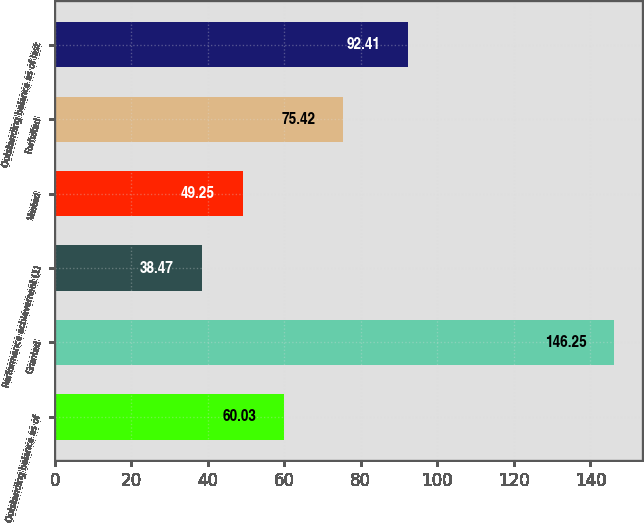<chart> <loc_0><loc_0><loc_500><loc_500><bar_chart><fcel>Outstanding balance as of<fcel>Granted<fcel>Performance achievement (1)<fcel>Vested<fcel>Forfeited<fcel>Outstanding balance as of last<nl><fcel>60.03<fcel>146.25<fcel>38.47<fcel>49.25<fcel>75.42<fcel>92.41<nl></chart> 